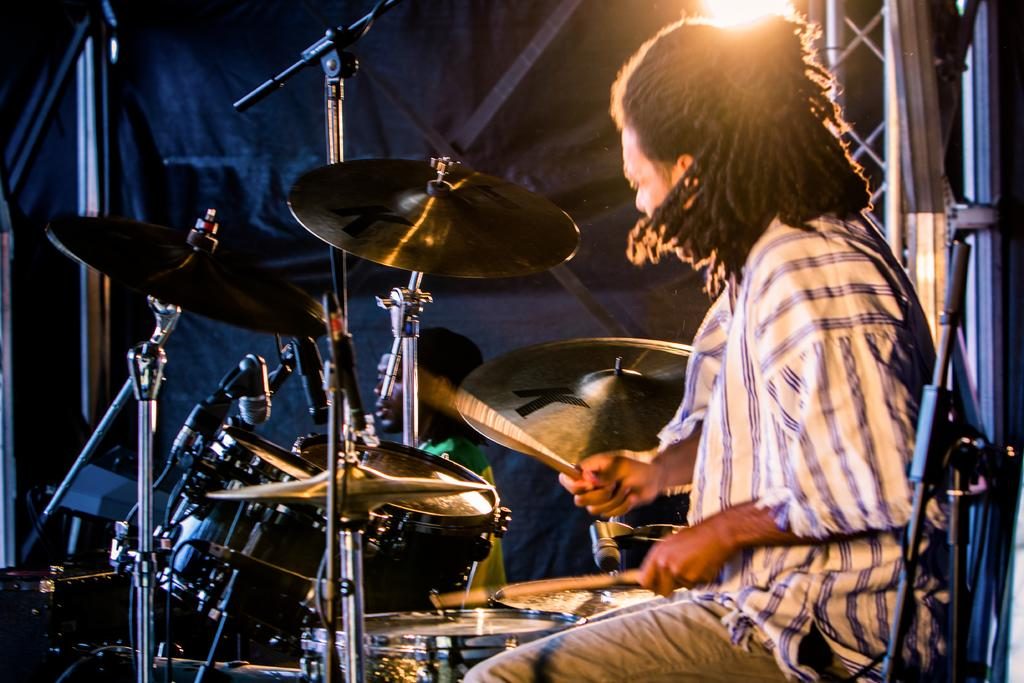What is the person in the image doing? The person is sitting on a chair in the image. What is the person holding in their hands? The person is holding musical instruments in their hands. Are there any other musical instruments visible in the image? Yes, there are musical instruments in the background of the image. What type of dinosaurs can be seen playing in the sand in the image? There are no dinosaurs or sand present in the image; it features a person holding musical instruments and other musical instruments in the background. 